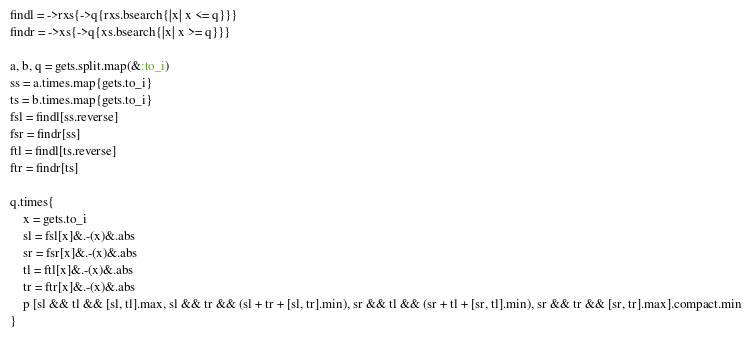Convert code to text. <code><loc_0><loc_0><loc_500><loc_500><_Ruby_>findl = ->rxs{->q{rxs.bsearch{|x| x <= q}}}
findr = ->xs{->q{xs.bsearch{|x| x >= q}}}

a, b, q = gets.split.map(&:to_i)
ss = a.times.map{gets.to_i}
ts = b.times.map{gets.to_i}
fsl = findl[ss.reverse]
fsr = findr[ss]
ftl = findl[ts.reverse]
ftr = findr[ts]

q.times{
    x = gets.to_i
    sl = fsl[x]&.-(x)&.abs
    sr = fsr[x]&.-(x)&.abs
    tl = ftl[x]&.-(x)&.abs
    tr = ftr[x]&.-(x)&.abs
    p [sl && tl && [sl, tl].max, sl && tr && (sl + tr + [sl, tr].min), sr && tl && (sr + tl + [sr, tl].min), sr && tr && [sr, tr].max].compact.min
}</code> 